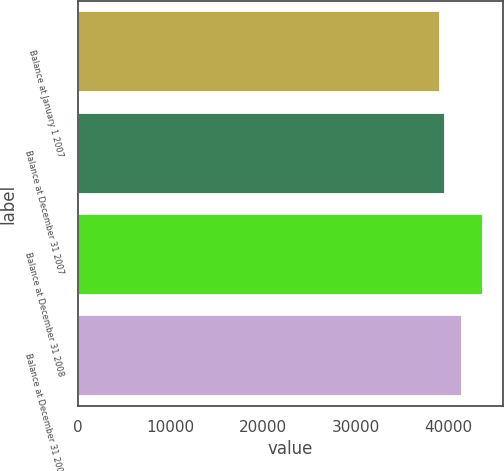<chart> <loc_0><loc_0><loc_500><loc_500><bar_chart><fcel>Balance at January 1 2007<fcel>Balance at December 31 2007<fcel>Balance at December 31 2008<fcel>Balance at December 31 2009<nl><fcel>39095.1<fcel>39555.5<fcel>43698.8<fcel>41404.9<nl></chart> 